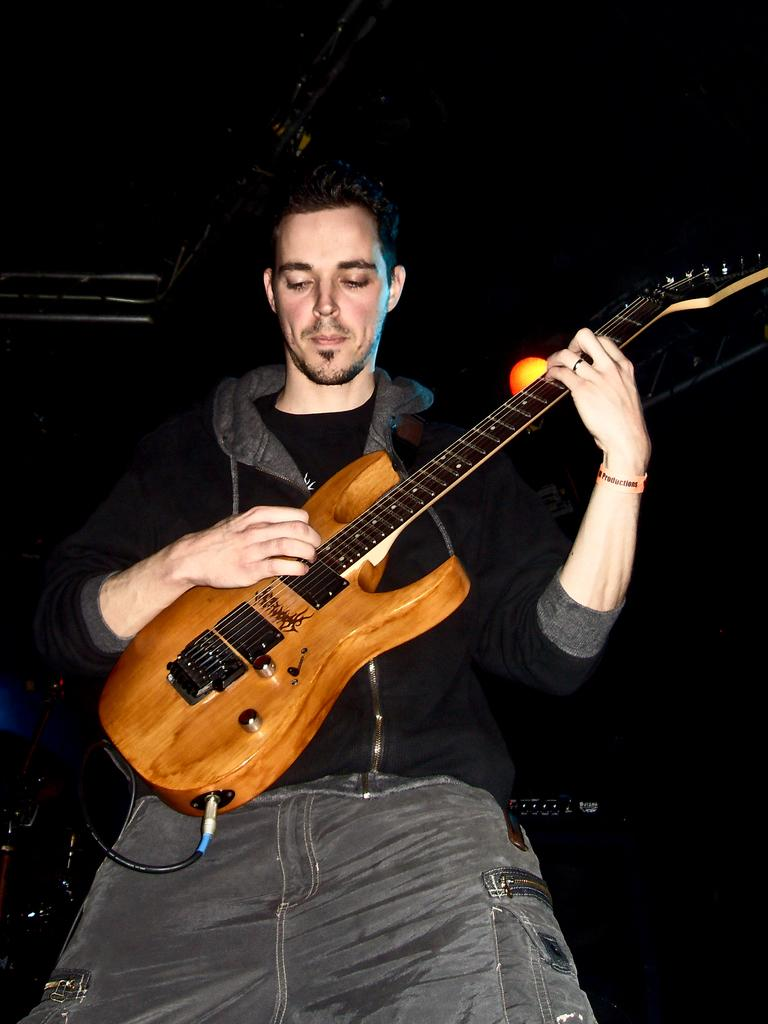What is the main subject of the image? There is a man in the image. What is the man doing in the image? The man is standing in the image. What object is the man holding in his hands? The man is holding a guitar in his hands. Can you describe the lighting in the image? There is a light visible in the image. What type of friction can be seen between the man's toes and the floor in the image? There is no information about the man's toes or the floor in the image, so it is not possible to determine the type of friction between them. 